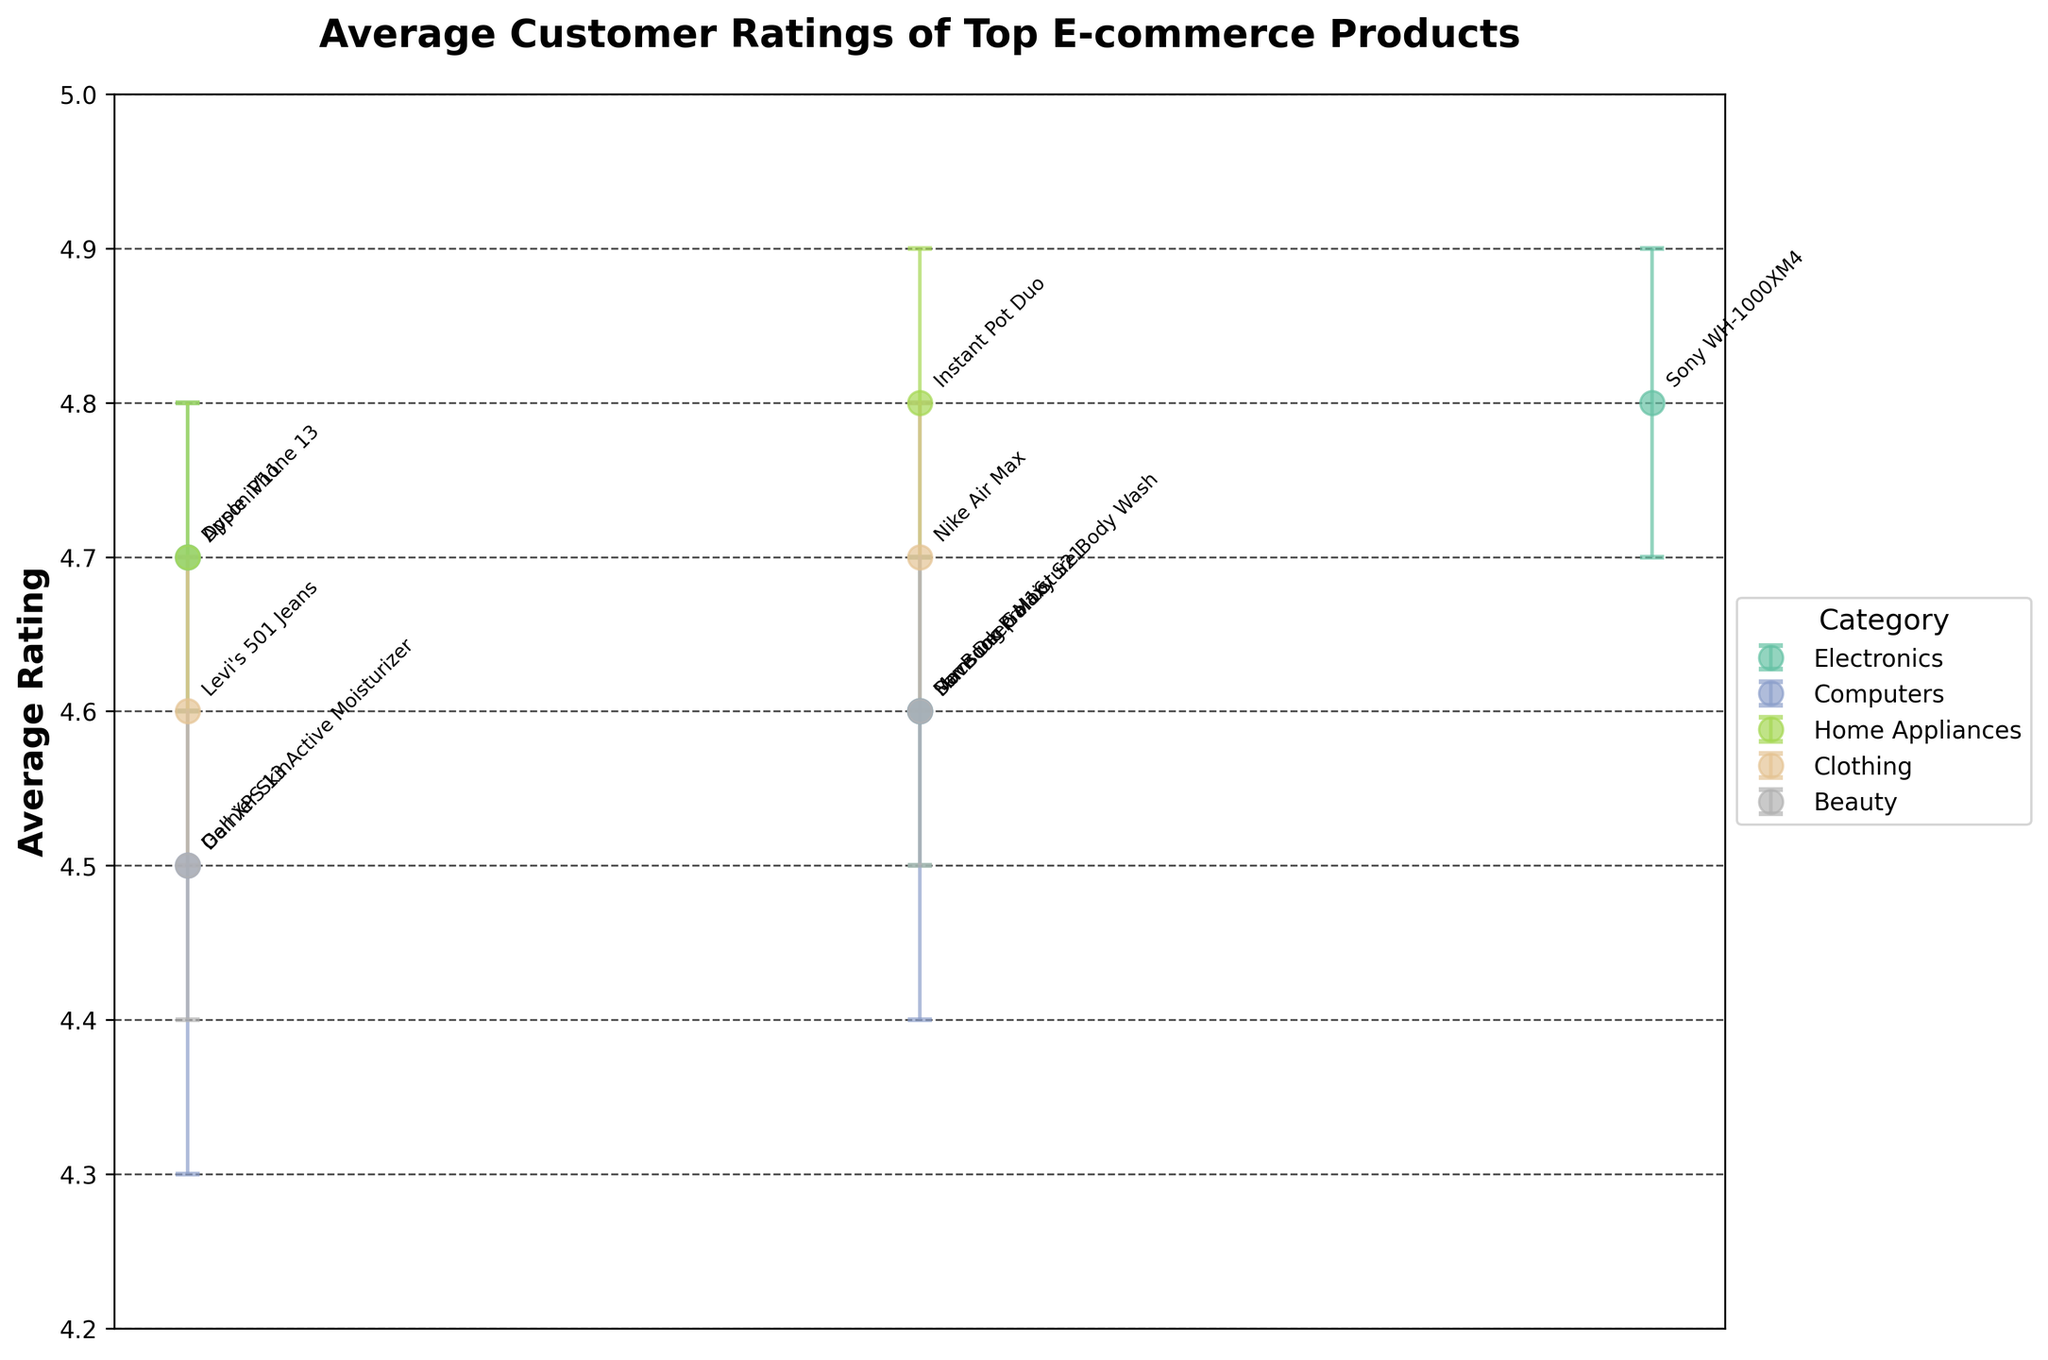What is the title of the figure? The title is displayed at the top of the figure. Look for the largest text that typically summarizes what the figure is about.
Answer: Average Customer Ratings of Top E-commerce Products Which product has the highest average rating? Look at all the error bars and identify the one that has the highest point.
Answer: Sony WH-1000XM4 and Instant Pot Duo What is the average rating of the Nike Air Max? Locate the error bar labeled "Nike Air Max" and read the numeric value of its central point.
Answer: 4.7 What is the confidence interval of the Dell XPS 13? Find the Dell XPS 13 in the figure, then identify the lower and upper bounds of the error bar for this product.
Answer: 4.3 to 4.7 Which category contains the most products? Count the number of labeled points in each category color and identify which one has the most.
Answer: Electronics Which product in the Electronics category has the narrowest confidence interval? Examine the error bars for all products in the Electronics category and determine which has the smallest range.
Answer: Sony WH-1000XM4 Compare the average ratings of Dove Deep Moisture Body Wash and Garnier SkinActive Moisturizer. Which one is higher? Locate both products and compare the central points of their error bars.
Answer: Dove Deep Moisture Body Wash What is the range of the confidence interval for MacBook Pro 16? Subtract the lower bound of the confidence interval from the upper bound for the MacBook Pro 16.
Answer: 0.4 What is the difference in average ratings between Apple iPhone 13 and Dell XPS 13? Subtract the average rating of Dell XPS 13 from the average rating of Apple iPhone 13.
Answer: 0.2 Which two products have the same confidence interval range? Compare the ranges of all confidence intervals by subtracting the lower bounds from the upper bounds and finding the products with matching results.
Answer: Apple iPhone 13 and Dyson V11 